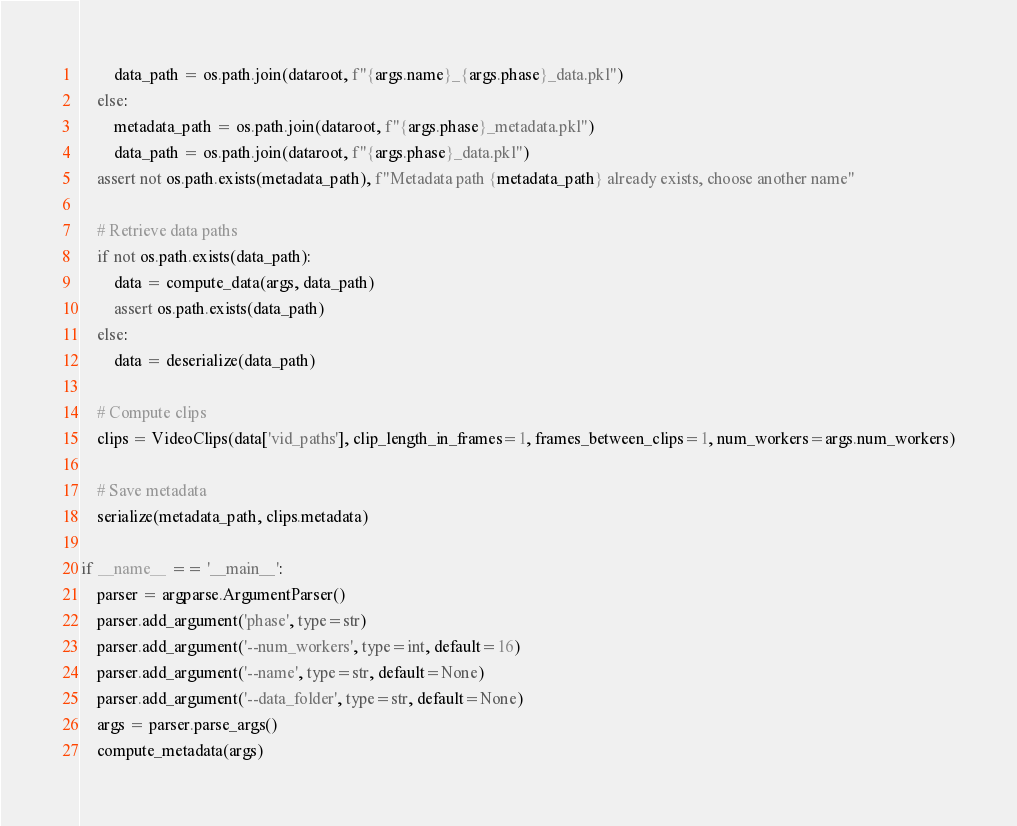Convert code to text. <code><loc_0><loc_0><loc_500><loc_500><_Python_>        data_path = os.path.join(dataroot, f"{args.name}_{args.phase}_data.pkl")
    else:
        metadata_path = os.path.join(dataroot, f"{args.phase}_metadata.pkl")
        data_path = os.path.join(dataroot, f"{args.phase}_data.pkl")
    assert not os.path.exists(metadata_path), f"Metadata path {metadata_path} already exists, choose another name"

    # Retrieve data paths
    if not os.path.exists(data_path):
        data = compute_data(args, data_path)
        assert os.path.exists(data_path)
    else:
        data = deserialize(data_path)

    # Compute clips
    clips = VideoClips(data['vid_paths'], clip_length_in_frames=1, frames_between_clips=1, num_workers=args.num_workers)

    # Save metadata
    serialize(metadata_path, clips.metadata)

if __name__ == '__main__':
    parser = argparse.ArgumentParser()
    parser.add_argument('phase', type=str)
    parser.add_argument('--num_workers', type=int, default=16)
    parser.add_argument('--name', type=str, default=None)
    parser.add_argument('--data_folder', type=str, default=None)
    args = parser.parse_args()
    compute_metadata(args)</code> 